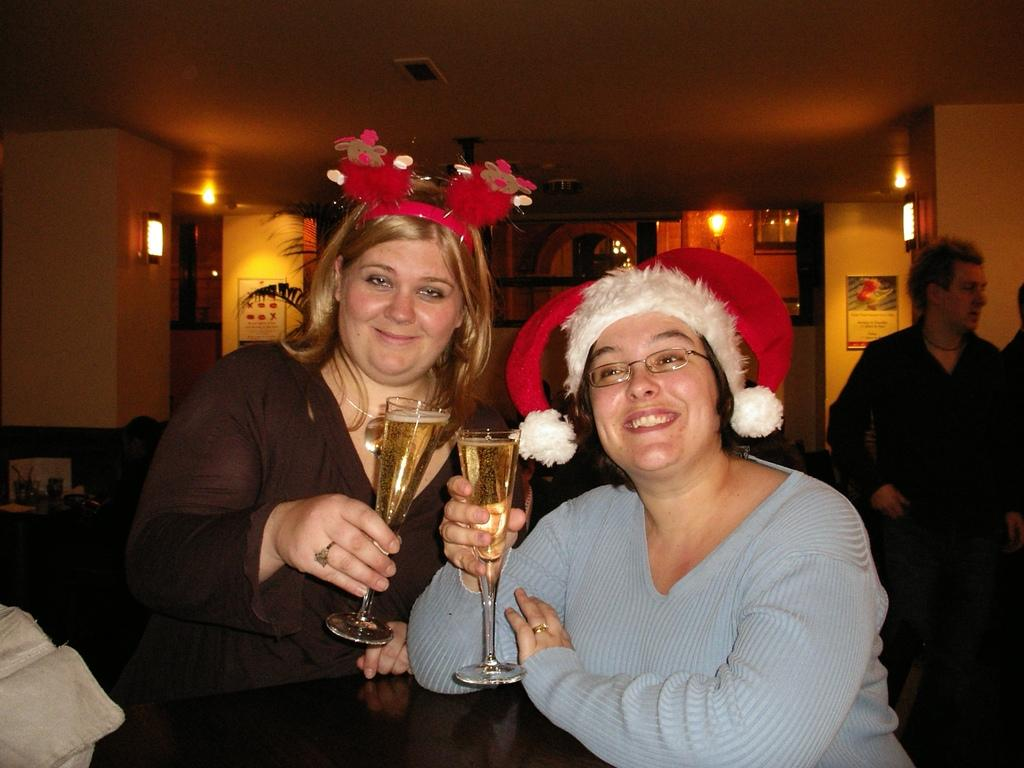How many people are in the image? There are two women in the image. What are the women doing in the image? The women are standing and holding glasses. What is inside the glasses the women are holding? The glasses contain liquid. Can you see any fog in the image? There is no fog present in the image. Are the women being attacked by any animals in the image? There are no animals or any indication of an attack in the image. 